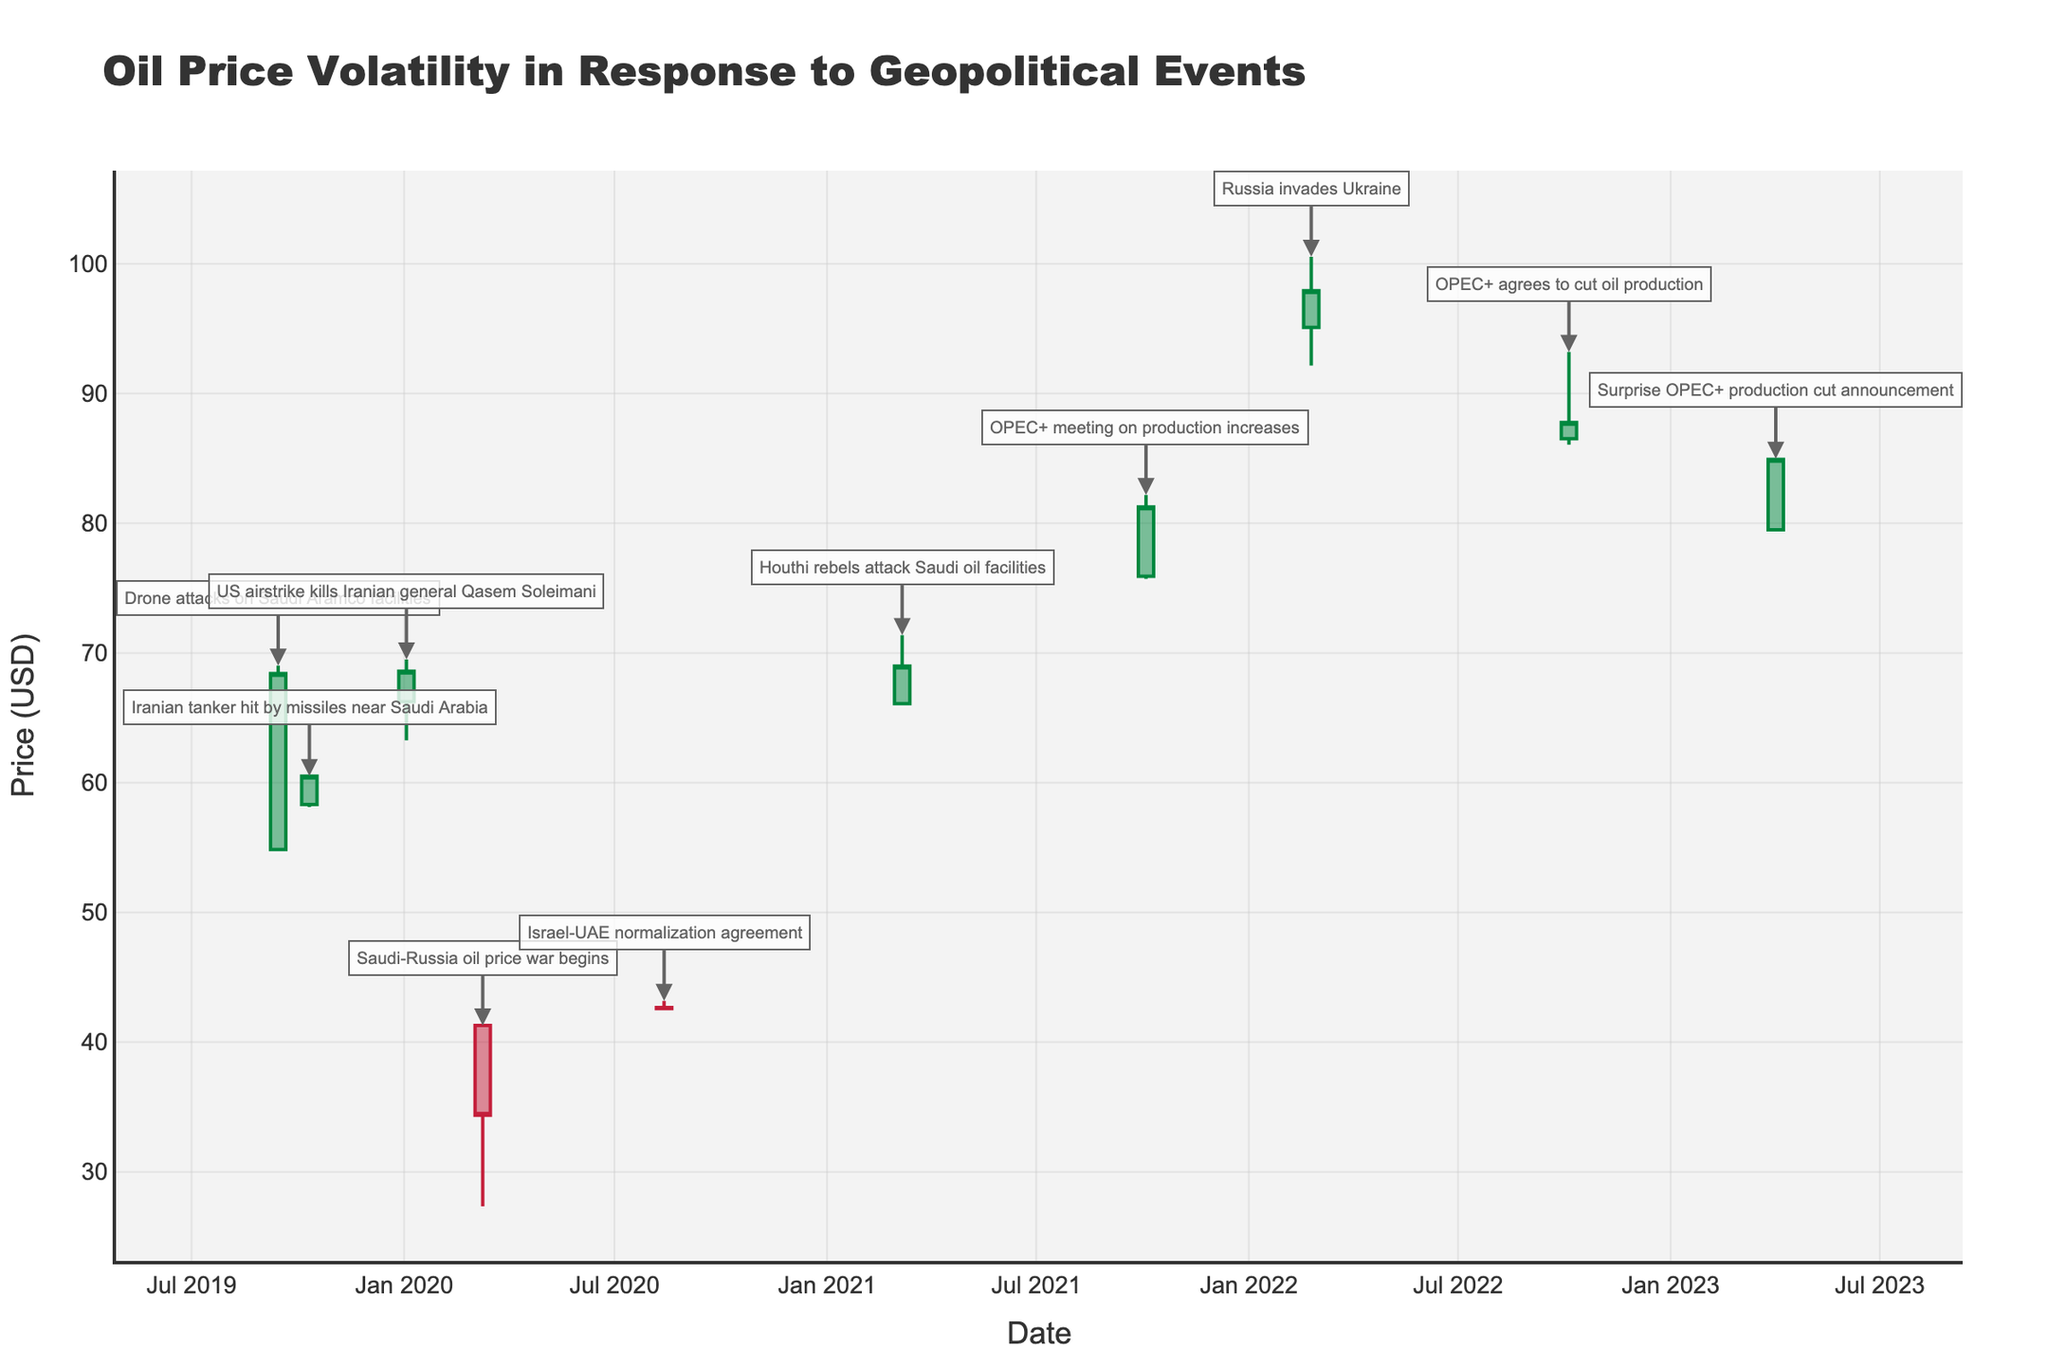What's the title of the figure? The title is placed at the top of the figure. It is "Oil Price Volatility in Response to Geopolitical Events."
Answer: Oil Price Volatility in Response to Geopolitical Events What are the axes titles? The x-axis title is located at the bottom and the y-axis title is on the left side of the figure. The x-axis is titled "Date" and the y-axis is titled "Price (USD)."
Answer: Date, Price (USD) How many major geopolitical events are annotated in the figure? The annotations, marked by arrows and text, point towards certain dates. By counting these annotations, we find there are 10 major geopolitical events.
Answer: 10 What was the highest oil price recorded after the US airstrike killing Iranian general Qasem Soleimani? Look for the OHLC bar corresponding to the date 2020-01-03 and check the highest price reached, which is indicated by the top of the bar. The highest price was $69.50.
Answer: $69.50 Which event led to the highest closing oil price? Identify the closing prices of each OHLC bar and correlate it with the events. The highest closing price is associated with the event on 2022-02-24, coinciding with the Russia-Ukraine war.
Answer: Russia invades Ukraine What was the price difference between the opening and closing prices on the start of the Saudi-Russia oil price war? Identify the bar for 2020-03-09, subtract the closing price from the opening price to find the difference (41.28 - 34.36). The difference is $6.92.
Answer: $6.92 Which two events caused the oil price to initially open below $50? Check the initial price (opening price) of each bar. Two such events are "Saudi-Russia oil price war begins" on 2020-03-09 and "Surprise OPEC+ production cut announcement" on 2023-04-02.
Answer: Saudi-Russia oil price war, Surprise OPEC+ production cut Was there a greater increase in oil price after OPEC+ meeting on 2021-10-04 or after OPEC+ agreed to cut oil production on 2022-10-05? Compare the increase in price from the opening to the closing of the bars for both dates. For 2021-10-04, the price increased from 75.92 to 81.26 ($5.34). For 2022-10-05, it increased from 86.52 to 87.76 ($1.24). The increase was greater on 2021-10-04.
Answer: OPEC+ meeting on 2021-10-04 What were the price ranges for oil on Aug 13, 2020, and Mar 7, 2021? Find the high and low prices from the respective OHLC bars. On 2020-08-13, the range was from 42.54 to 43.18. On 2021-03-07, it was from 65.98 to 71.38. The ranges are 2020-08-13: (42.54, 43.18), 2021-03-07: (65.98, 71.38).
Answer: 2020-08-13: (42.54, 43.18), 2021-03-07: (65.98, 71.38) Which event had the smallest difference between the highest and lowest prices? Calculate the difference between the high and low prices for each event. The smallest difference is for "Israel-UAE normalization agreement" on 2020-08-13 with a range of (43.18 - 42.54). The smallest difference is $0.64.
Answer: Israel-UAE normalization agreement 